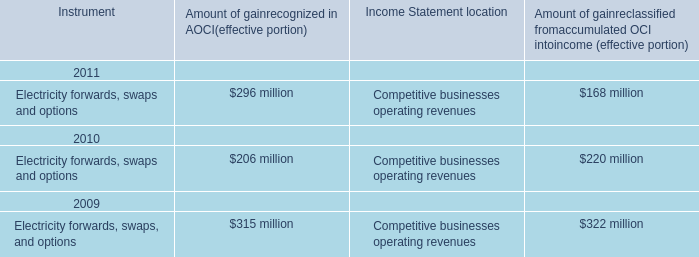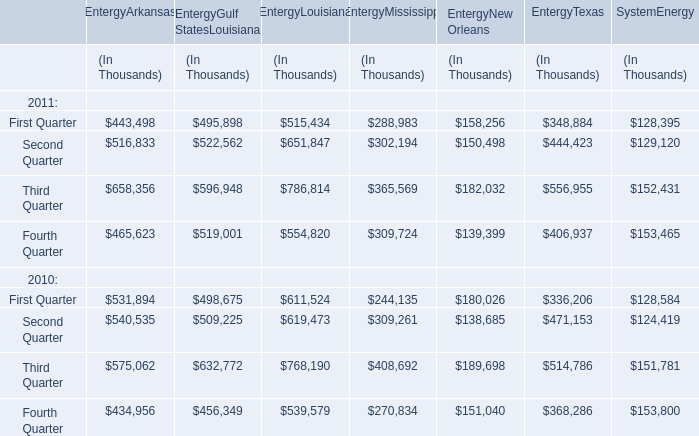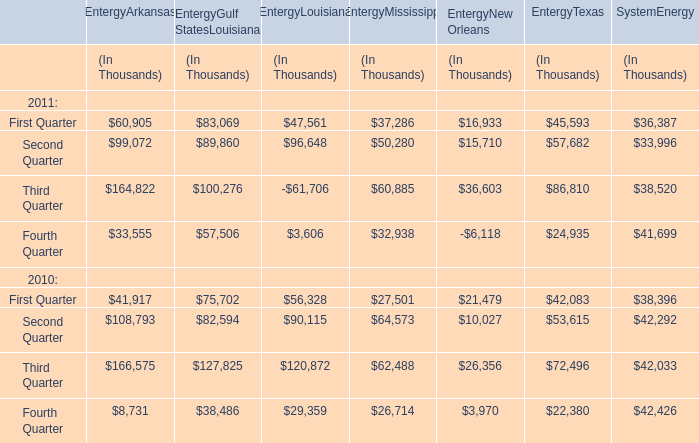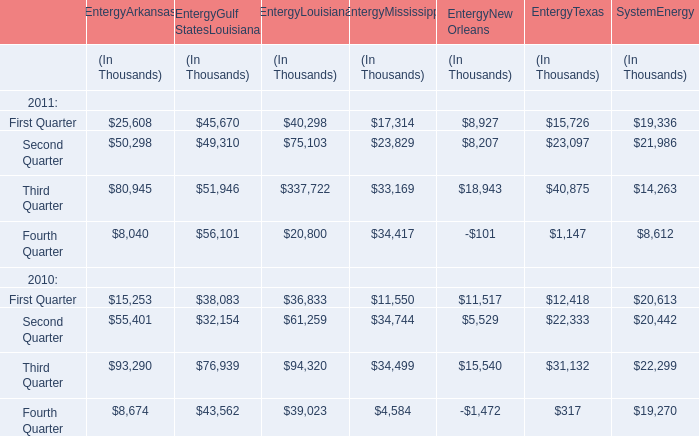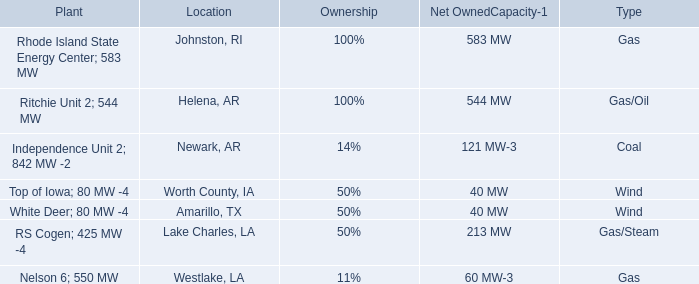What is the proportion of all elements for EntergyArkansas that are greater than 500000 to the total amount of elements, in 2011?? 
Computations: ((516833 + 658356) / (((443498 + 465623) + 516833) + 658356))
Answer: 0.56383. 